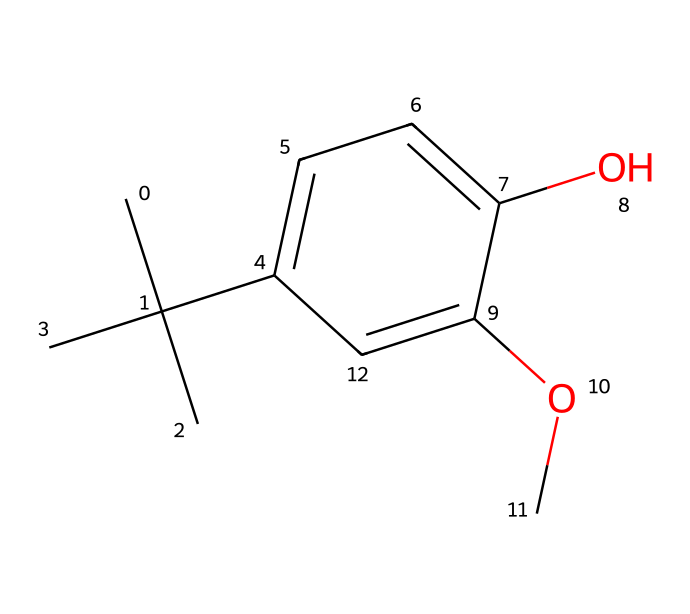What is the common name for the substance represented by this SMILES? The SMILES represents a chemical structure that corresponds to butylated hydroxyanisole, commonly abbreviated as BHA.
Answer: butylated hydroxyanisole How many carbon atoms are in the structure of BHA? By analyzing the SMILES representation, we can count the number of 'C' symbols. There are a total of 11 carbon atoms in the structure.
Answer: 11 What type of chemical functional groups are present in BHA? The structure shows a hydroxyl group (-OH) and a methoxy group (-OCH3). These are the key functional groups identified in the chemical structure.
Answer: hydroxyl and methoxy What is the total number of oxygen atoms in BHA? The SMILES indicates that there are two oxygen atoms present in the structure, one from the hydroxyl group and another from the methoxy group.
Answer: 2 What does the presence of the hydroxyl group suggest about BHA's properties? The hydroxyl group typically contributes to the solubility of compounds in water and may enhance the antioxidant properties of BHA, which is significant for its function as a preservative.
Answer: antioxidant properties What kind of chemical is BHA classified as? Based on its usage as a food preservative and its structural characteristics, BHA is classified as an antioxidant.
Answer: antioxidant How does BHA help in preserving snacks? BHA acts by stabilizing fats and oils in food products, preventing them from oxidation, which prolongs shelf life and maintains flavor.
Answer: prevents oxidation 